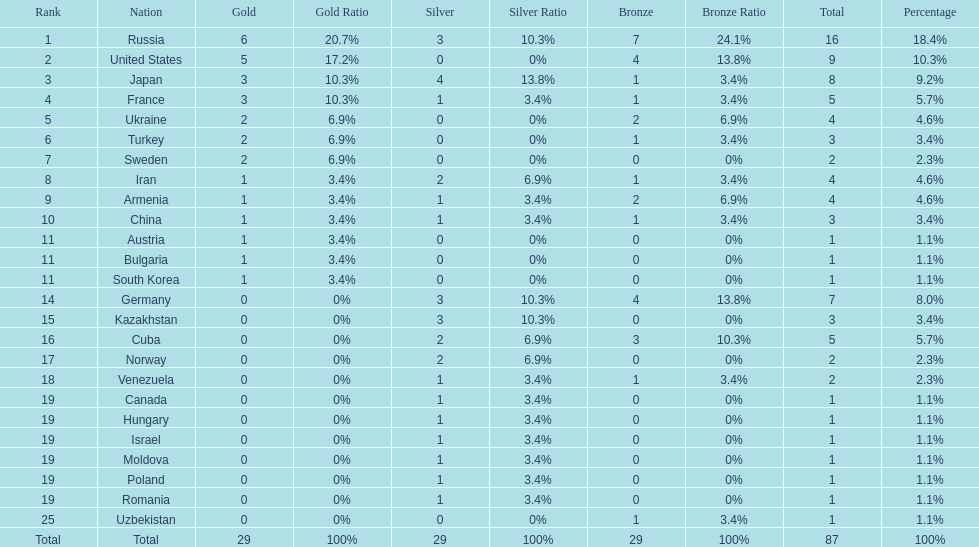Who won more gold medals than the united states? Russia. 